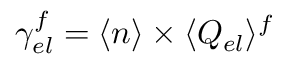Convert formula to latex. <formula><loc_0><loc_0><loc_500><loc_500>\gamma _ { e l } ^ { f } = \langle n \rangle \times \langle Q _ { e l } \rangle ^ { f }</formula> 